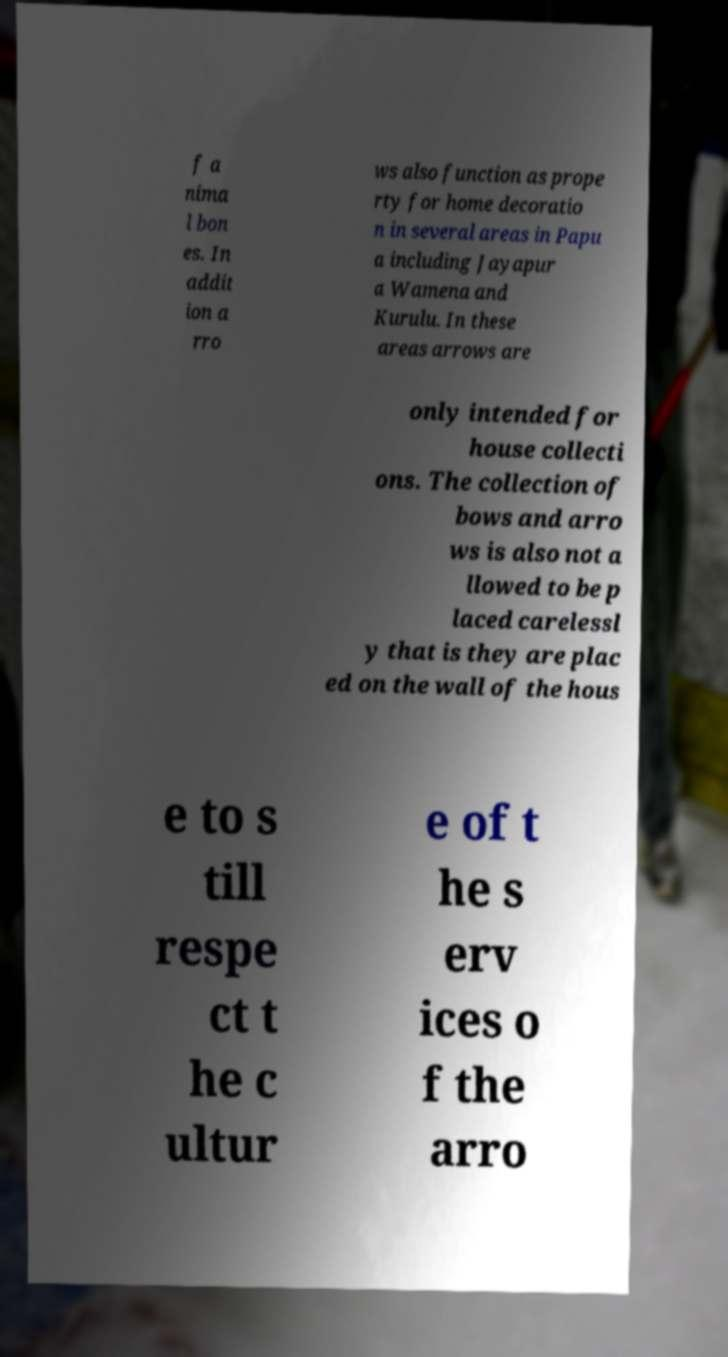Could you extract and type out the text from this image? f a nima l bon es. In addit ion a rro ws also function as prope rty for home decoratio n in several areas in Papu a including Jayapur a Wamena and Kurulu. In these areas arrows are only intended for house collecti ons. The collection of bows and arro ws is also not a llowed to be p laced carelessl y that is they are plac ed on the wall of the hous e to s till respe ct t he c ultur e of t he s erv ices o f the arro 